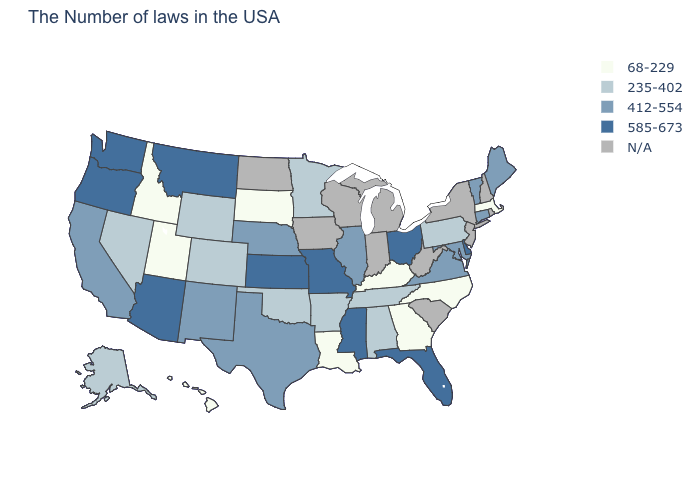Does the map have missing data?
Answer briefly. Yes. Which states hav the highest value in the West?
Be succinct. Montana, Arizona, Washington, Oregon. Is the legend a continuous bar?
Give a very brief answer. No. Name the states that have a value in the range 235-402?
Quick response, please. Pennsylvania, Alabama, Tennessee, Arkansas, Minnesota, Oklahoma, Wyoming, Colorado, Nevada, Alaska. Which states have the lowest value in the USA?
Be succinct. Massachusetts, North Carolina, Georgia, Kentucky, Louisiana, South Dakota, Utah, Idaho, Hawaii. What is the lowest value in the USA?
Be succinct. 68-229. Does the first symbol in the legend represent the smallest category?
Write a very short answer. Yes. What is the value of Mississippi?
Keep it brief. 585-673. What is the value of Kansas?
Be succinct. 585-673. Name the states that have a value in the range 585-673?
Be succinct. Delaware, Ohio, Florida, Mississippi, Missouri, Kansas, Montana, Arizona, Washington, Oregon. Name the states that have a value in the range 585-673?
Write a very short answer. Delaware, Ohio, Florida, Mississippi, Missouri, Kansas, Montana, Arizona, Washington, Oregon. What is the lowest value in states that border South Carolina?
Answer briefly. 68-229. 